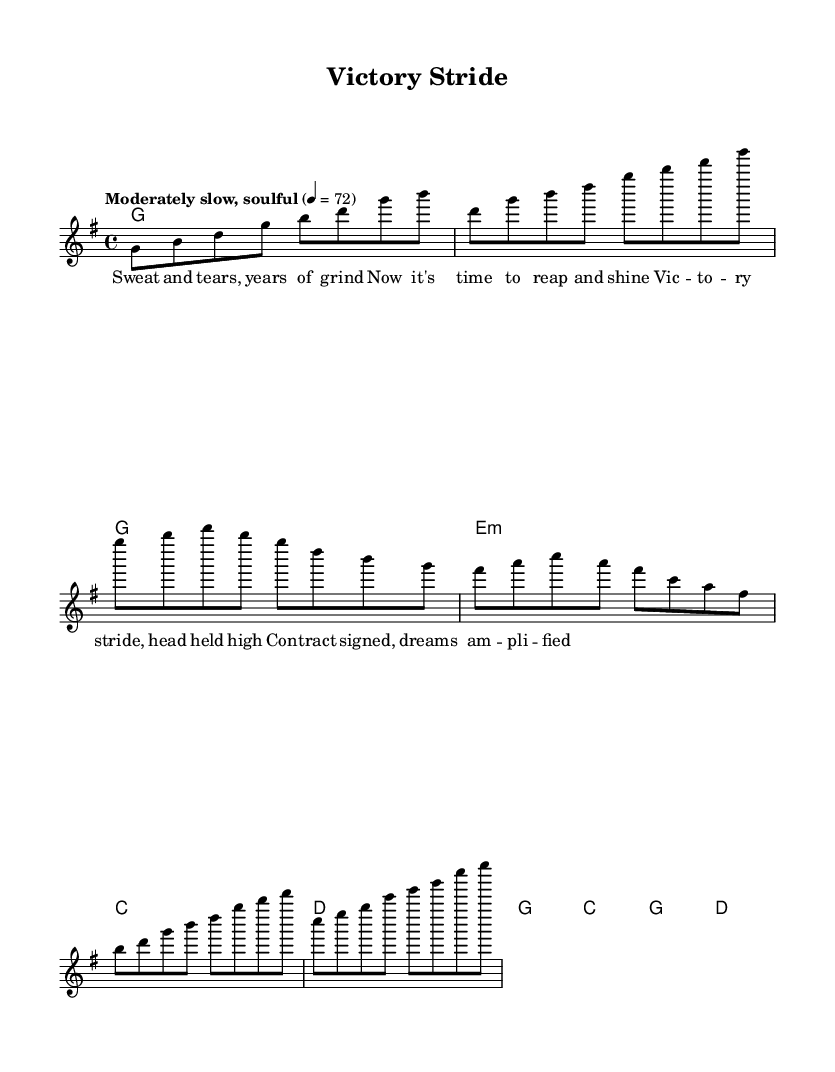What is the key signature of this music? The key signature is G major, which has one sharp (F#). This can be identified by looking at the key signature notation at the beginning of the staff.
Answer: G major What is the time signature of the piece? The time signature is 4/4, which indicates four beats per measure. This is shown at the beginning of the sheet music, giving a clear indication of the rhythmic structure.
Answer: 4/4 What is the tempo marking of the music? The tempo marking states "Moderately slow, soulful" with a metronome marking of 72. This indicates the character and speed of the music, found in the tempo section at the start.
Answer: Moderately slow, soulful How many measures are in the verse section? The verse section contains 4 measures. By counting the grouped notation in the melody line (each vertical line represents a measure), we can see the number of distinct measures in that section.
Answer: 4 What chord is played during the chorus? The chorus features the chords G, C, G, and D as highlighted in the harmonies section. These chords are crucial for establishing the harmonic foundation during the chorus.
Answer: G, C, G, D What lyrical theme is expressed in the chorus? The theme expressed in the chorus conveys a sense of triumph and accomplishment, as indicated by the lyrics "Vic -- to -- ry stride, head held high." This reflects the overall theme of celebrating victories and success.
Answer: Triumph and accomplishment How does the tempo contribute to the style of Rhythm and Blues? The moderately slow tempo contributes to the soulful feel of Rhythm and Blues, allowing for expressive phrasing and emotional delivery. This is characteristic of the genre and helps accentuate the heartfelt lyrics.
Answer: Soulful feel 